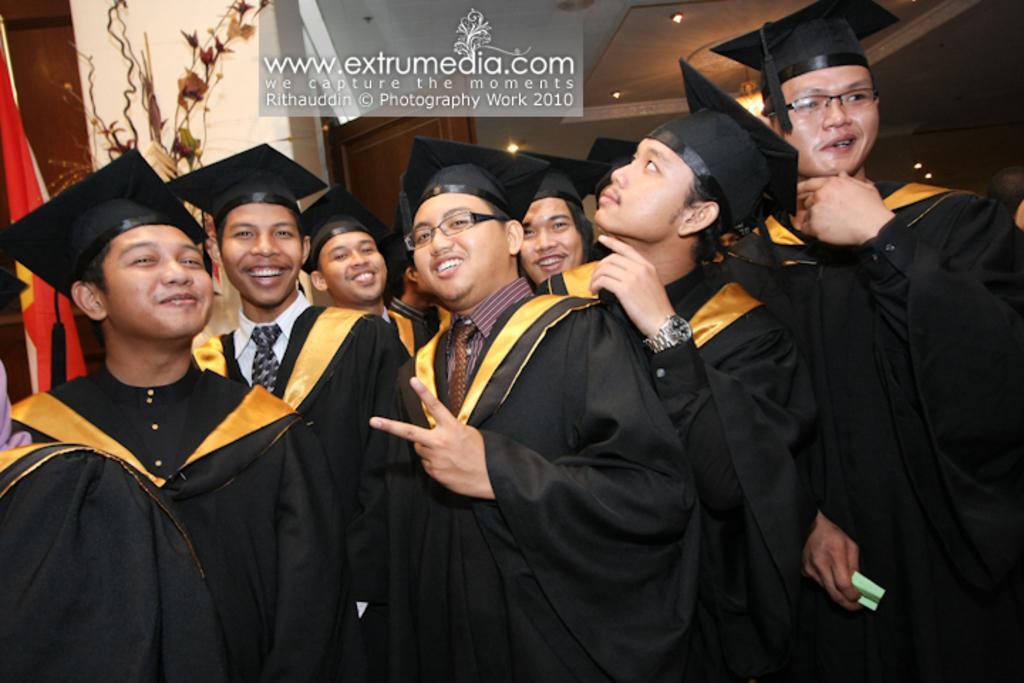Can you describe this image briefly? In this image there are people standing wearing graduation dress, at the top there is some text. 